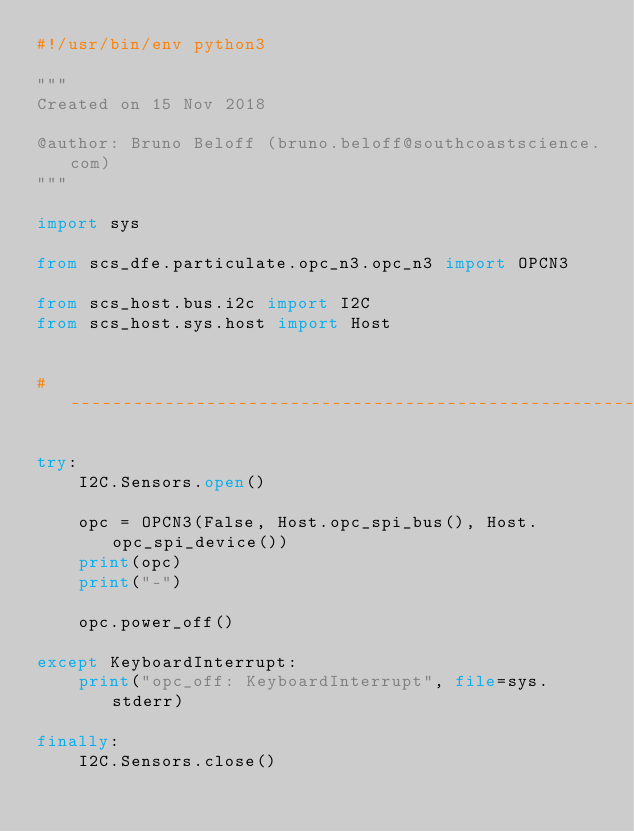<code> <loc_0><loc_0><loc_500><loc_500><_Python_>#!/usr/bin/env python3

"""
Created on 15 Nov 2018

@author: Bruno Beloff (bruno.beloff@southcoastscience.com)
"""

import sys

from scs_dfe.particulate.opc_n3.opc_n3 import OPCN3

from scs_host.bus.i2c import I2C
from scs_host.sys.host import Host


# --------------------------------------------------------------------------------------------------------------------

try:
    I2C.Sensors.open()

    opc = OPCN3(False, Host.opc_spi_bus(), Host.opc_spi_device())
    print(opc)
    print("-")

    opc.power_off()

except KeyboardInterrupt:
    print("opc_off: KeyboardInterrupt", file=sys.stderr)

finally:
    I2C.Sensors.close()
</code> 